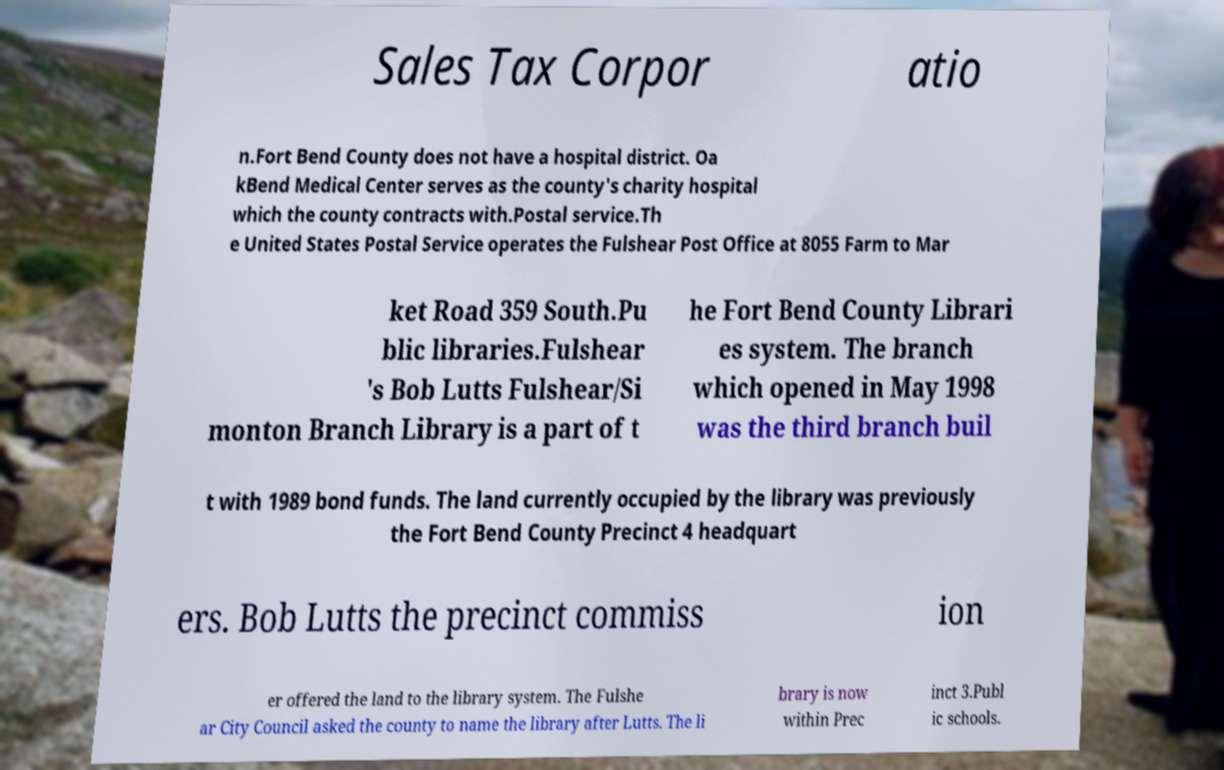For documentation purposes, I need the text within this image transcribed. Could you provide that? Sales Tax Corpor atio n.Fort Bend County does not have a hospital district. Oa kBend Medical Center serves as the county's charity hospital which the county contracts with.Postal service.Th e United States Postal Service operates the Fulshear Post Office at 8055 Farm to Mar ket Road 359 South.Pu blic libraries.Fulshear 's Bob Lutts Fulshear/Si monton Branch Library is a part of t he Fort Bend County Librari es system. The branch which opened in May 1998 was the third branch buil t with 1989 bond funds. The land currently occupied by the library was previously the Fort Bend County Precinct 4 headquart ers. Bob Lutts the precinct commiss ion er offered the land to the library system. The Fulshe ar City Council asked the county to name the library after Lutts. The li brary is now within Prec inct 3.Publ ic schools. 